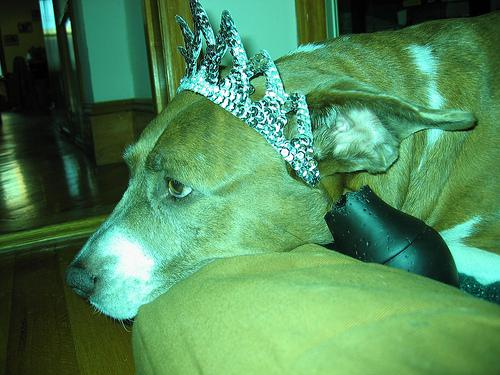Question: what color is the dog?
Choices:
A. Brown and black.
B. Grey and tan.
C. Amber and cream.
D. Yellowish-brown and white.
Answer with the letter. Answer: D 